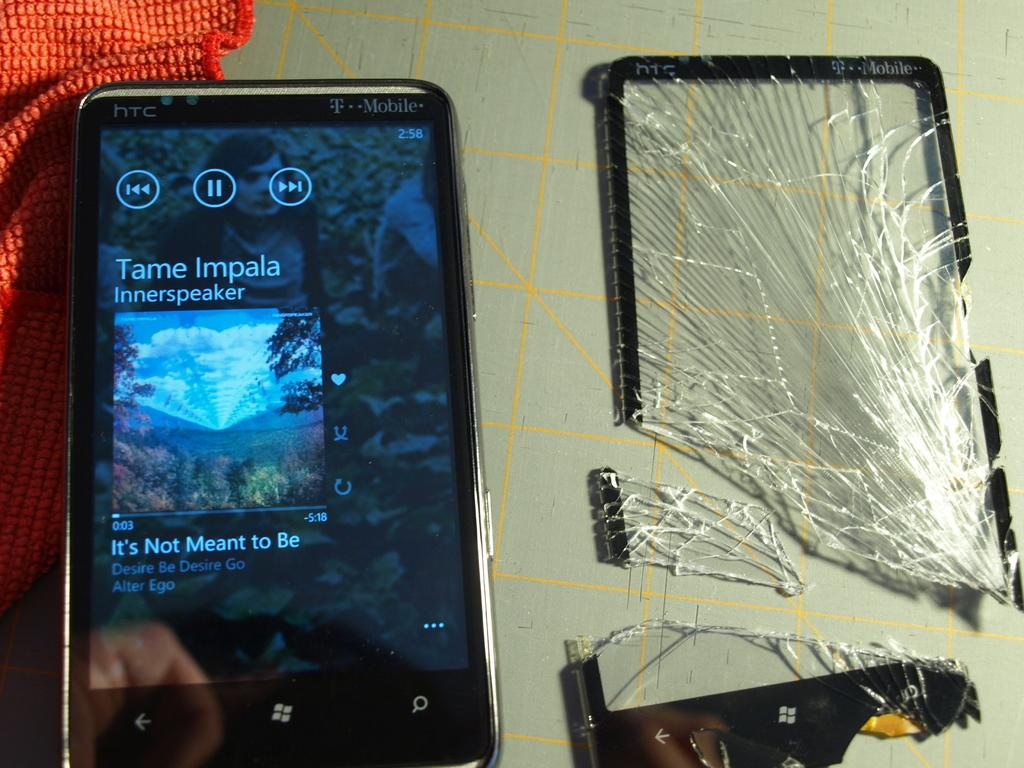<image>
Relay a brief, clear account of the picture shown. The owner of this phone is going to play the song It's not Meant to be. 